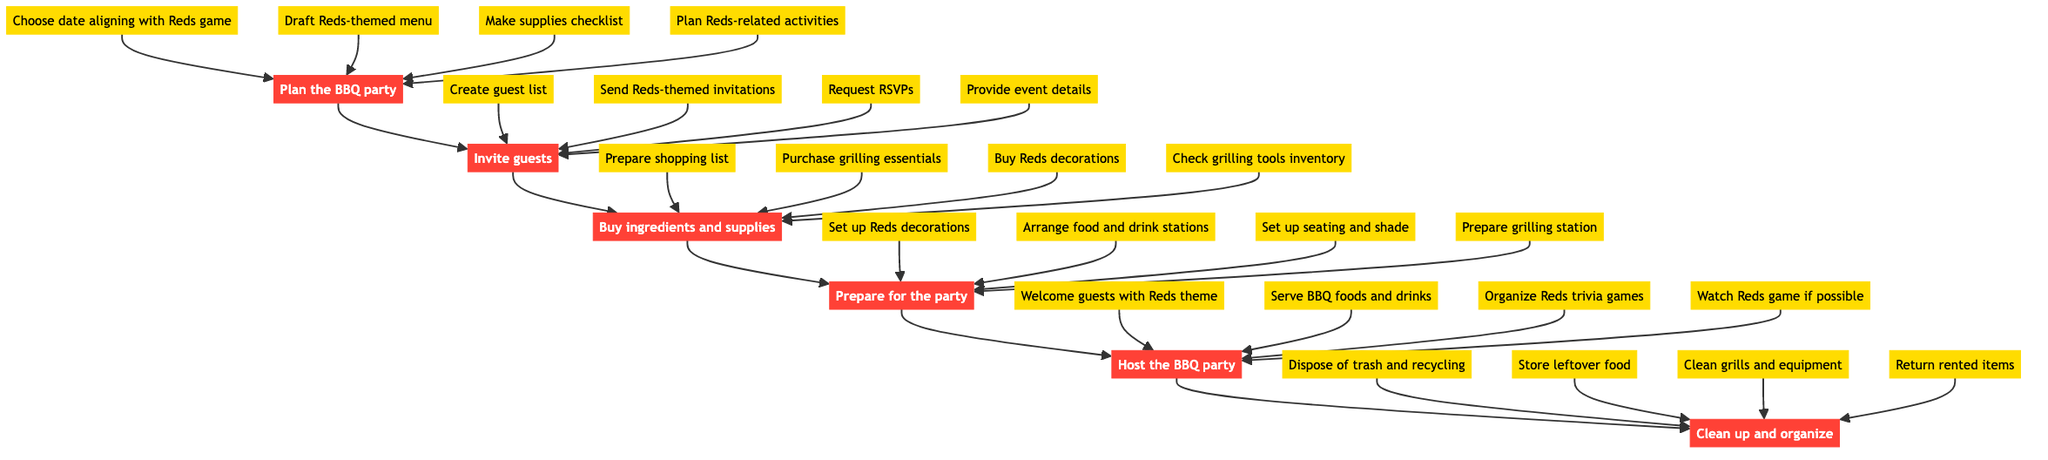What is the final step in the process? The flow chart indicates that the last task to complete after hosting the BBQ party is ‘Clean up and organize.’ This is located at the top of the flow chart.
Answer: Clean up and organize How many main steps are there in organizing the BBQ? The flow chart displays six main steps that lead to hosting the BBQ party. Each step is a separate node in the flow of the diagram.
Answer: Six Which task involves sending out invitations? In the diagram, sending out invitations is a part of the ‘Invite guests’ node. This node follows the ‘Plan the BBQ party’ node and is essential for inviting attendees.
Answer: Invite guests What must be prepared before hosting the BBQ? The second-to-last step in the diagram corresponds to ‘Prepare for the party.’ It involves various tasks vital to setting up for the event before guests arrive.
Answer: Prepare for the party What is the primary objective during the event? The ‘Host the BBQ party’ node encapsulates the main activities to perform when guests arrive, which are aimed at providing a fun and engaging experience.
Answer: Host the BBQ party What is the first task to initiate the BBQ planning process? The first task to kick off the planning is ‘Choose a date aligning with Reds game,’ which helps ensure the party coincides with a sports event for better attendance.
Answer: Choose date aligning with Reds game How many details are listed under ‘Setup’? There are four specific details listed under the ‘Prepare for the party’ node, which comprises the various tasks to set up for the event effectively.
Answer: Four How are the party activities related to the Reds? The task labeled ‘Organize Reds trivia games and activities’ under the ‘Host the BBQ party’ node shows that the activities are themed concerning the Cincinnati Reds, ensuring a cohesive experience.
Answer: Organize Reds trivia games and activities Which task requires the creation of a shopping list? The task ‘Prepare a shopping list with foods and drinks’ falls under ‘Buy ingredients and supplies,’ indicating that it is essential to gather everything needed for the BBQ.
Answer: Buy ingredients and supplies 